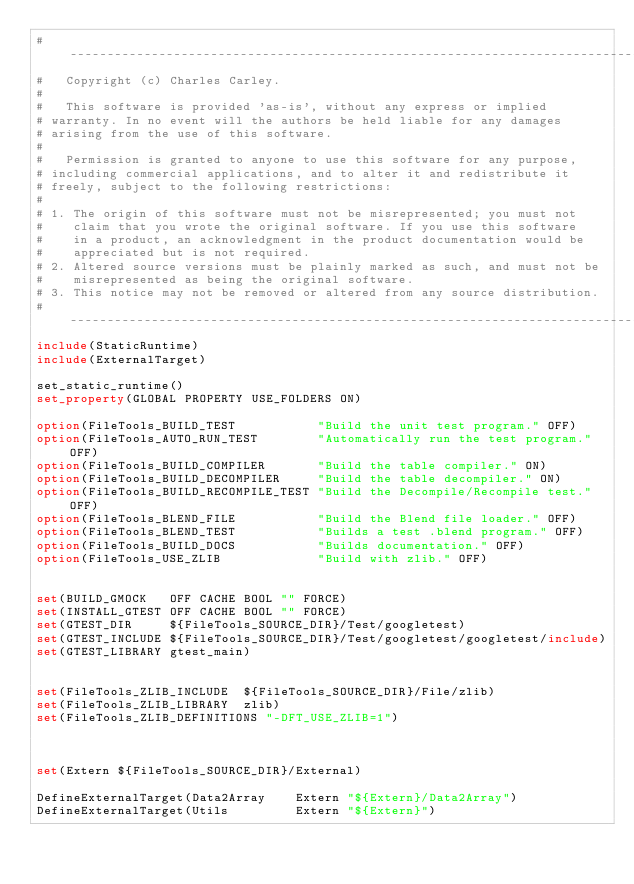<code> <loc_0><loc_0><loc_500><loc_500><_CMake_># -----------------------------------------------------------------------------
#   Copyright (c) Charles Carley.
#
#   This software is provided 'as-is', without any express or implied
# warranty. In no event will the authors be held liable for any damages
# arising from the use of this software.
#
#   Permission is granted to anyone to use this software for any purpose,
# including commercial applications, and to alter it and redistribute it
# freely, subject to the following restrictions:
#
# 1. The origin of this software must not be misrepresented; you must not
#    claim that you wrote the original software. If you use this software
#    in a product, an acknowledgment in the product documentation would be
#    appreciated but is not required.
# 2. Altered source versions must be plainly marked as such, and must not be
#    misrepresented as being the original software.
# 3. This notice may not be removed or altered from any source distribution.
# ------------------------------------------------------------------------------
include(StaticRuntime)
include(ExternalTarget)

set_static_runtime()
set_property(GLOBAL PROPERTY USE_FOLDERS ON)

option(FileTools_BUILD_TEST           "Build the unit test program." OFF)
option(FileTools_AUTO_RUN_TEST        "Automatically run the test program." OFF)
option(FileTools_BUILD_COMPILER       "Build the table compiler." ON)
option(FileTools_BUILD_DECOMPILER     "Build the table decompiler." ON)
option(FileTools_BUILD_RECOMPILE_TEST "Build the Decompile/Recompile test." OFF)
option(FileTools_BLEND_FILE           "Build the Blend file loader." OFF)
option(FileTools_BLEND_TEST           "Builds a test .blend program." OFF)
option(FileTools_BUILD_DOCS           "Builds documentation." OFF)
option(FileTools_USE_ZLIB             "Build with zlib." OFF)


set(BUILD_GMOCK   OFF CACHE BOOL "" FORCE)
set(INSTALL_GTEST OFF CACHE BOOL "" FORCE)
set(GTEST_DIR     ${FileTools_SOURCE_DIR}/Test/googletest)
set(GTEST_INCLUDE ${FileTools_SOURCE_DIR}/Test/googletest/googletest/include)
set(GTEST_LIBRARY gtest_main)


set(FileTools_ZLIB_INCLUDE  ${FileTools_SOURCE_DIR}/File/zlib)
set(FileTools_ZLIB_LIBRARY  zlib)
set(FileTools_ZLIB_DEFINITIONS "-DFT_USE_ZLIB=1")



set(Extern ${FileTools_SOURCE_DIR}/External)

DefineExternalTarget(Data2Array    Extern "${Extern}/Data2Array")
DefineExternalTarget(Utils         Extern "${Extern}")
</code> 